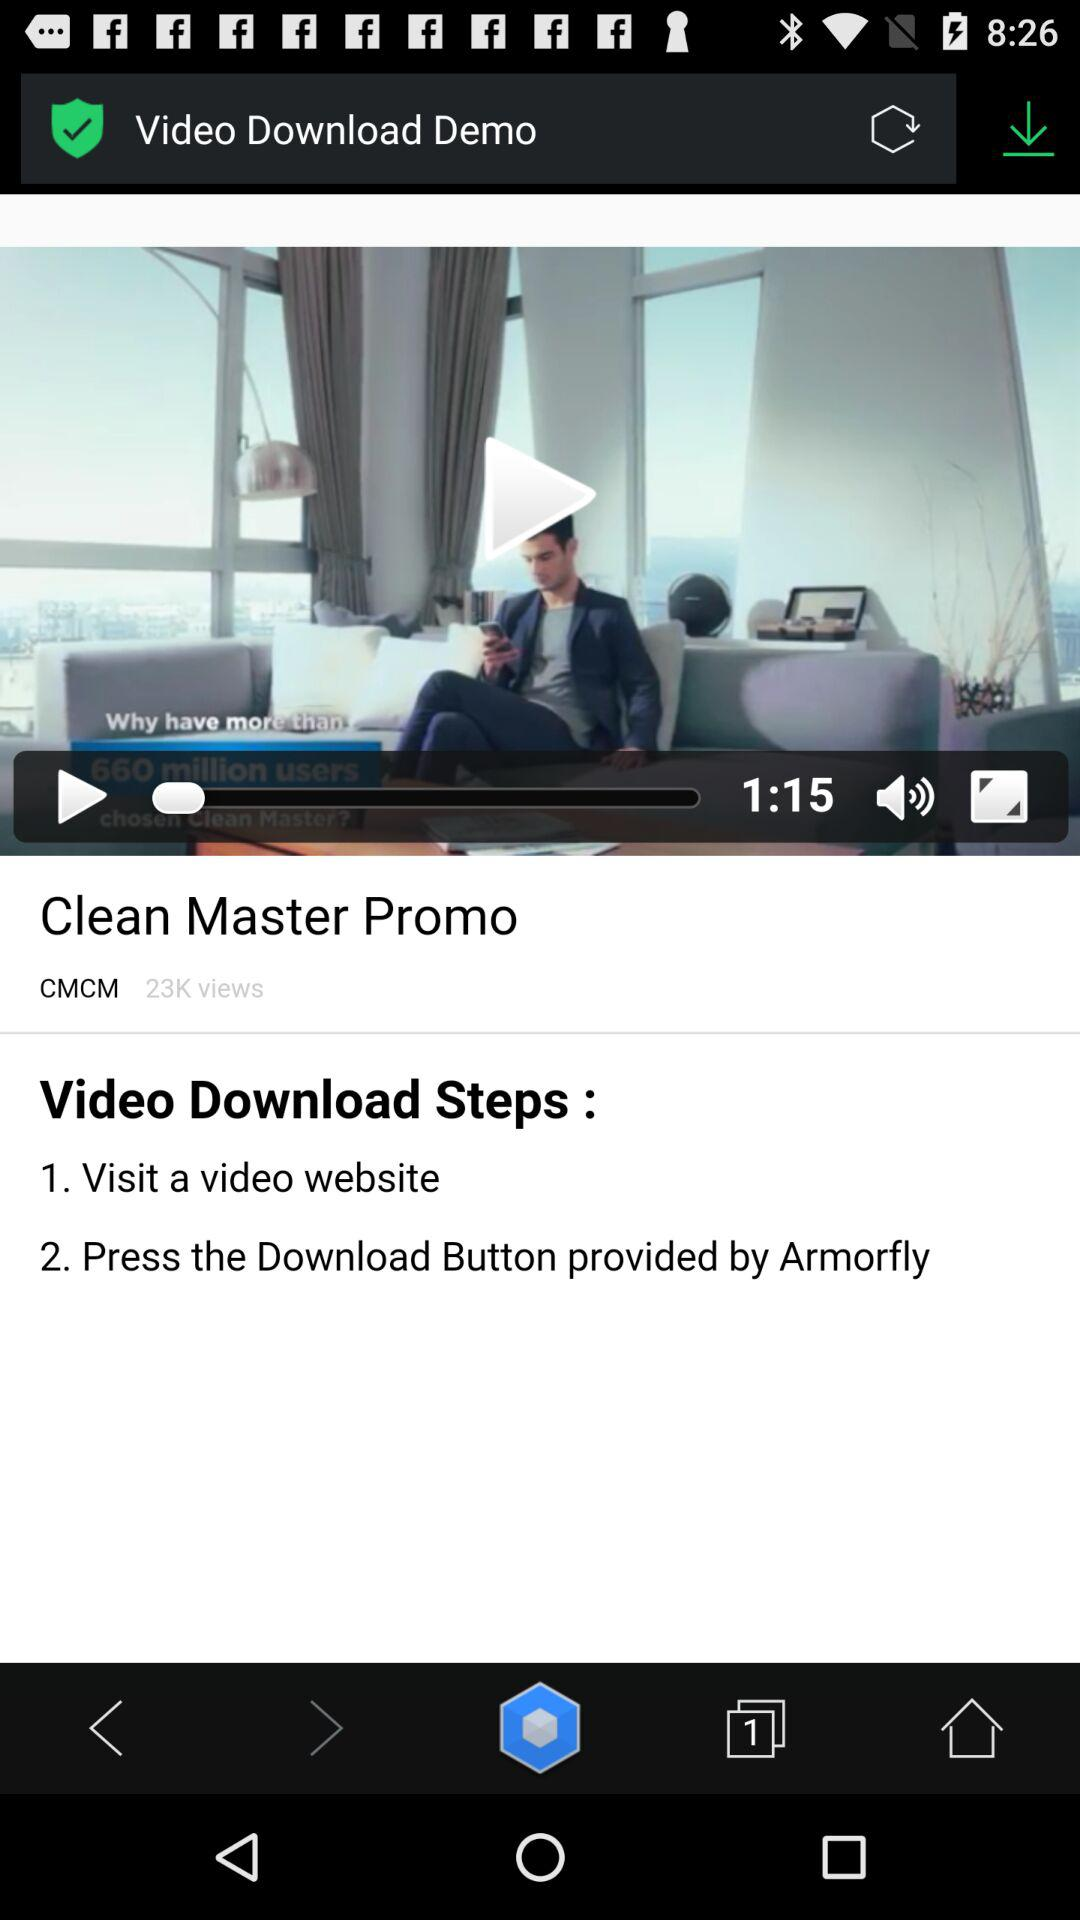What is the total duration of the video? The total duration of the video is 1 minute and 15 seconds. 